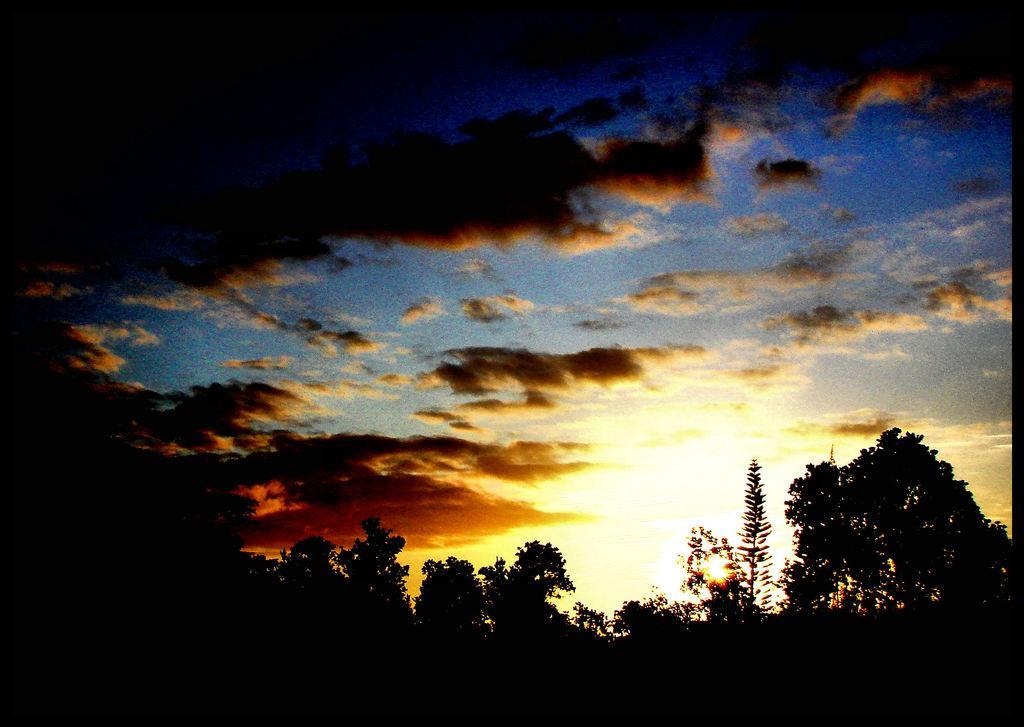Could you give a brief overview of what you see in this image? In this image I can see many trees. In the background I can see the clouds and the sky. 